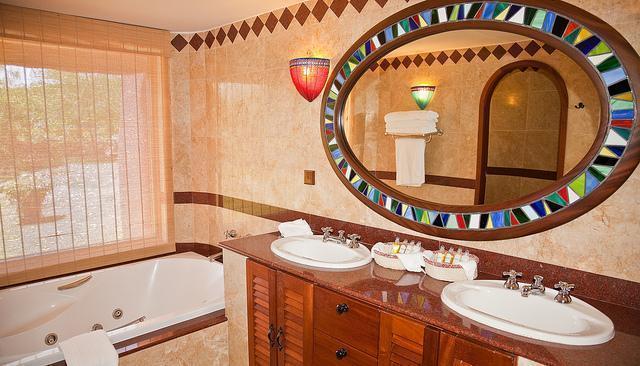What materials likely make up the colorful frame of the mirror?
Answer the question by selecting the correct answer among the 4 following choices.
Options: Metal, terra cotta, porcelain, concrete. Porcelain. Why does the tub have round silver objects on it?
Select the accurate answer and provide explanation: 'Answer: answer
Rationale: rationale.'
Options: Hot water, drainage, childs toys, whirlpool. Answer: whirlpool.
Rationale: The tub is a whirlpool. 